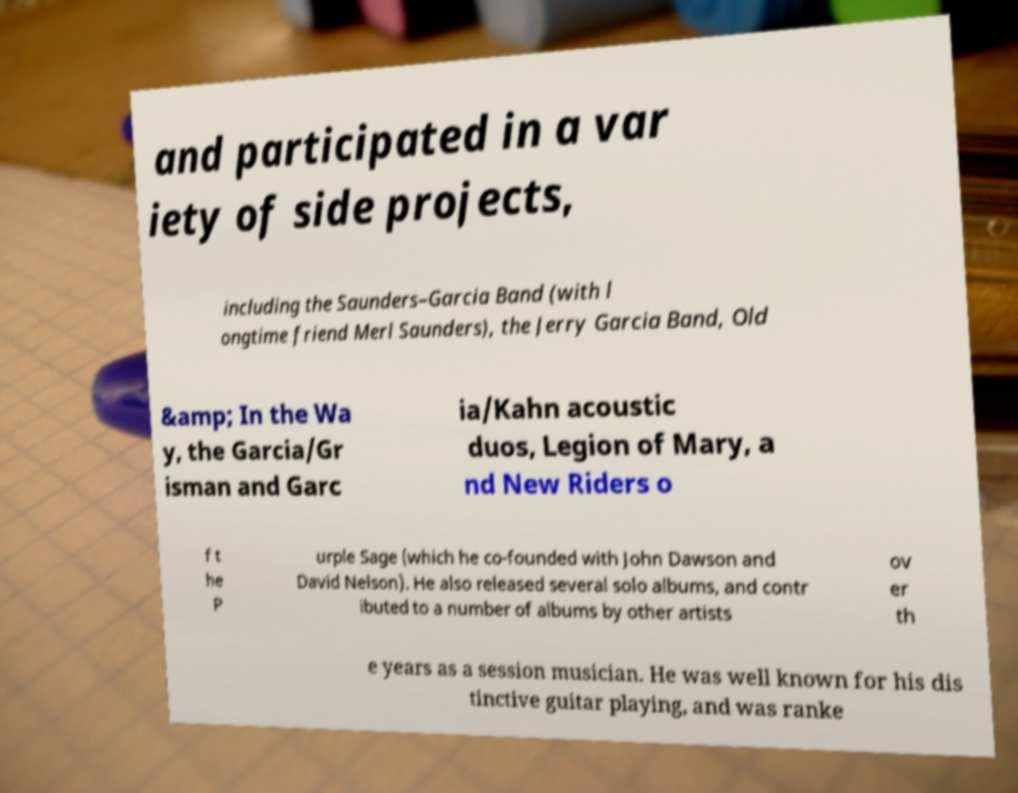Can you accurately transcribe the text from the provided image for me? and participated in a var iety of side projects, including the Saunders–Garcia Band (with l ongtime friend Merl Saunders), the Jerry Garcia Band, Old &amp; In the Wa y, the Garcia/Gr isman and Garc ia/Kahn acoustic duos, Legion of Mary, a nd New Riders o f t he P urple Sage (which he co-founded with John Dawson and David Nelson). He also released several solo albums, and contr ibuted to a number of albums by other artists ov er th e years as a session musician. He was well known for his dis tinctive guitar playing, and was ranke 